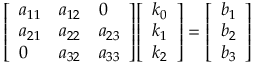<formula> <loc_0><loc_0><loc_500><loc_500>{ \left [ \begin{array} { l l l } { a _ { 1 1 } } & { a _ { 1 2 } } & { 0 } \\ { a _ { 2 1 } } & { a _ { 2 2 } } & { a _ { 2 3 } } \\ { 0 } & { a _ { 3 2 } } & { a _ { 3 3 } } \end{array} \right ] } { \left [ \begin{array} { l } { k _ { 0 } } \\ { k _ { 1 } } \\ { k _ { 2 } } \end{array} \right ] } = { \left [ \begin{array} { l } { b _ { 1 } } \\ { b _ { 2 } } \\ { b _ { 3 } } \end{array} \right ] }</formula> 